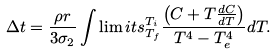<formula> <loc_0><loc_0><loc_500><loc_500>\Delta t = \frac { \rho r } { 3 \sigma _ { 2 } } \int \lim i t s _ { T _ { f } } ^ { T _ { i } } \frac { \left ( C + T \frac { d C } { d T } \right ) } { T ^ { 4 } - T _ { e } ^ { 4 } } d T .</formula> 